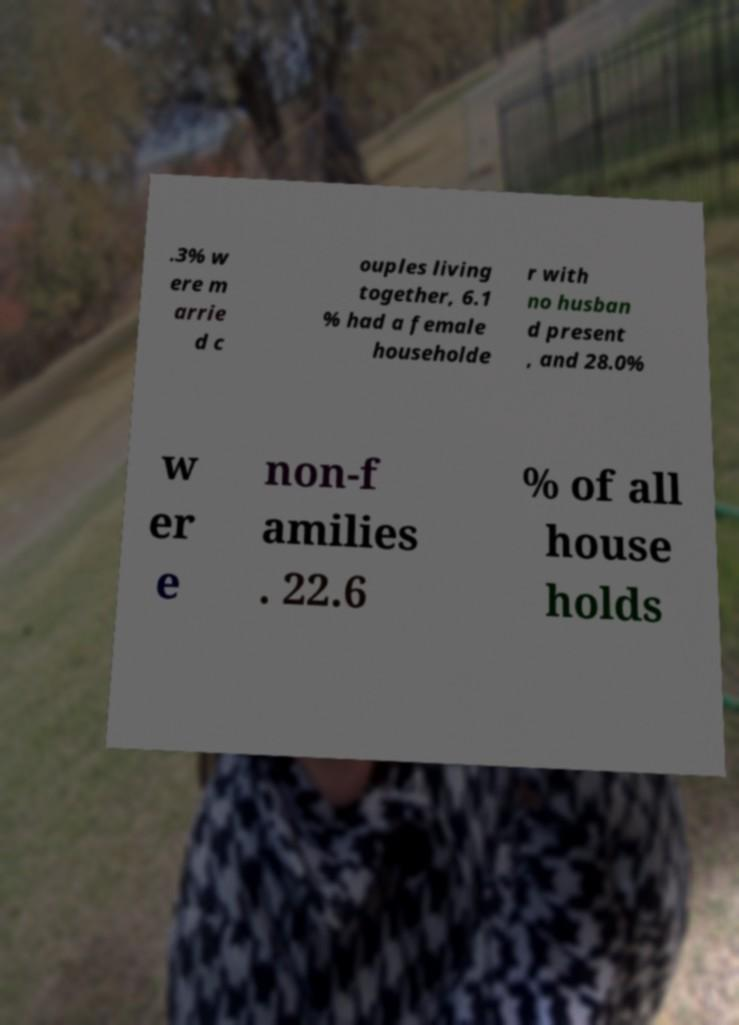Can you read and provide the text displayed in the image?This photo seems to have some interesting text. Can you extract and type it out for me? .3% w ere m arrie d c ouples living together, 6.1 % had a female householde r with no husban d present , and 28.0% w er e non-f amilies . 22.6 % of all house holds 